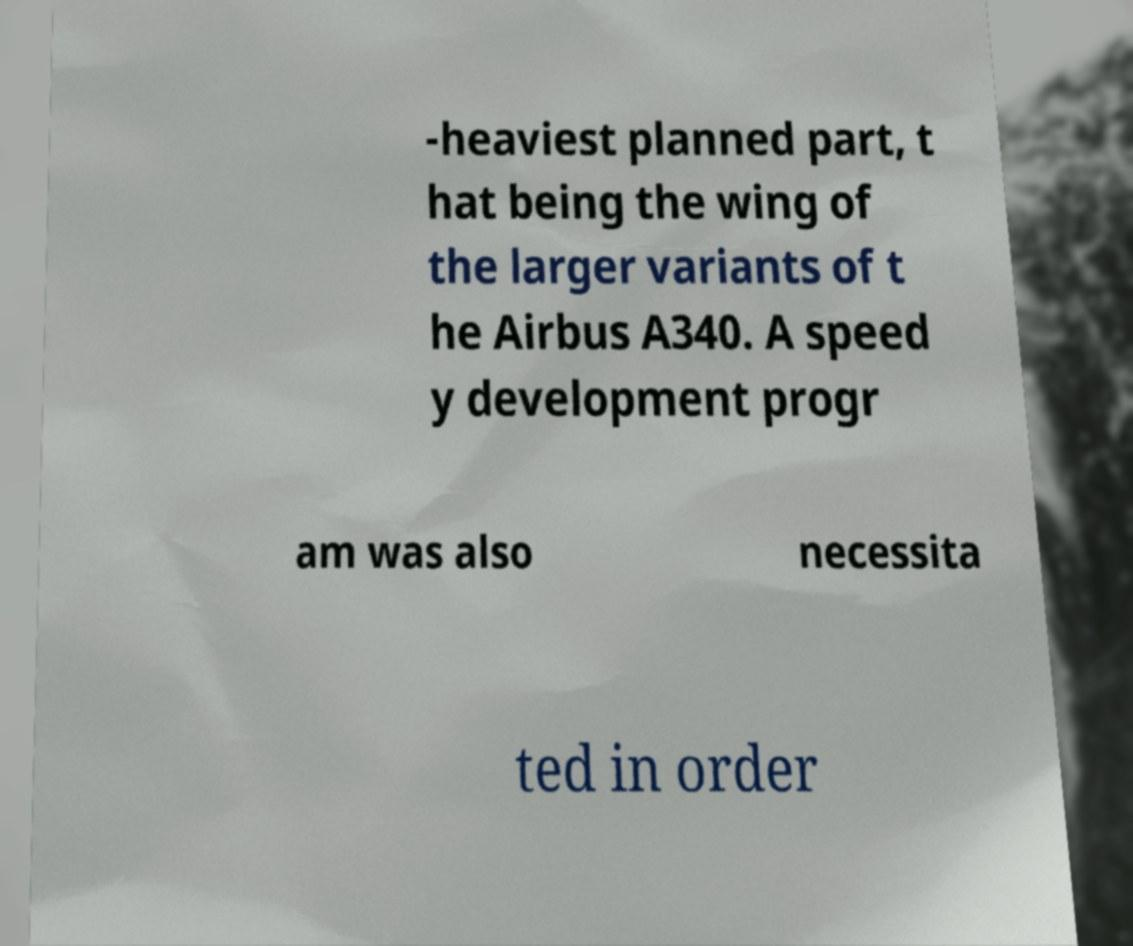I need the written content from this picture converted into text. Can you do that? -heaviest planned part, t hat being the wing of the larger variants of t he Airbus A340. A speed y development progr am was also necessita ted in order 